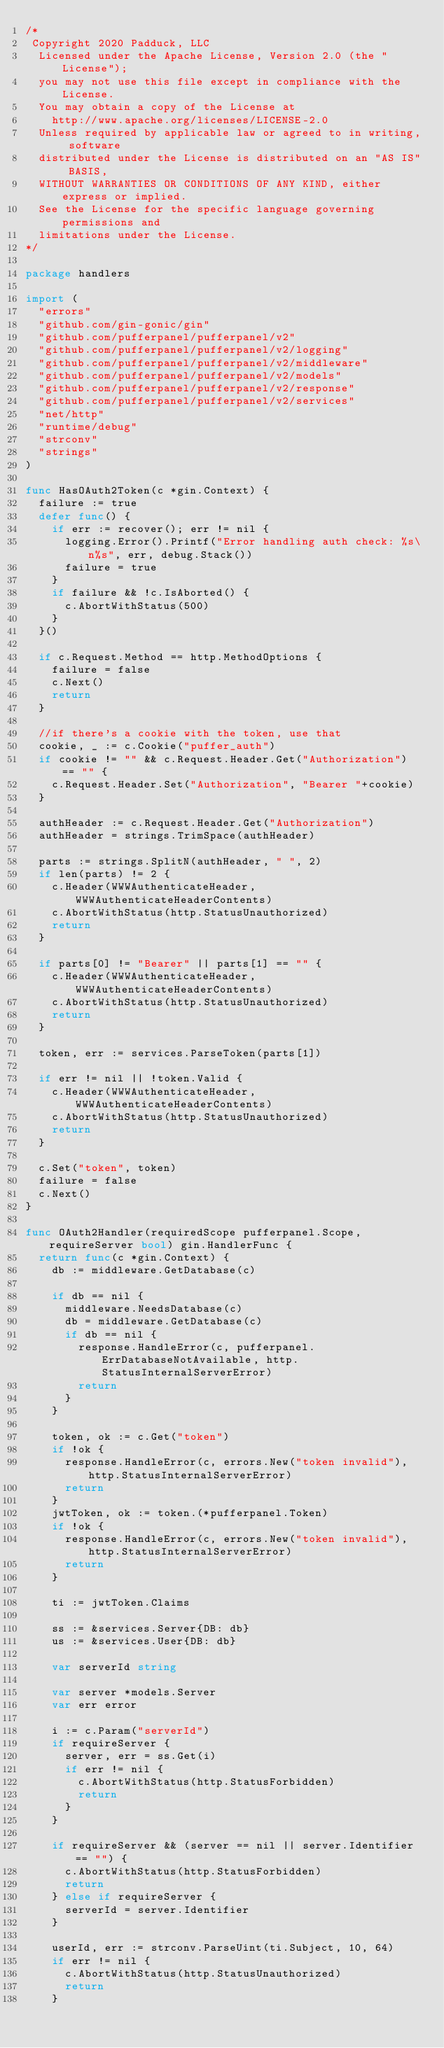Convert code to text. <code><loc_0><loc_0><loc_500><loc_500><_Go_>/*
 Copyright 2020 Padduck, LLC
  Licensed under the Apache License, Version 2.0 (the "License");
  you may not use this file except in compliance with the License.
  You may obtain a copy of the License at
  	http://www.apache.org/licenses/LICENSE-2.0
  Unless required by applicable law or agreed to in writing, software
  distributed under the License is distributed on an "AS IS" BASIS,
  WITHOUT WARRANTIES OR CONDITIONS OF ANY KIND, either express or implied.
  See the License for the specific language governing permissions and
  limitations under the License.
*/

package handlers

import (
	"errors"
	"github.com/gin-gonic/gin"
	"github.com/pufferpanel/pufferpanel/v2"
	"github.com/pufferpanel/pufferpanel/v2/logging"
	"github.com/pufferpanel/pufferpanel/v2/middleware"
	"github.com/pufferpanel/pufferpanel/v2/models"
	"github.com/pufferpanel/pufferpanel/v2/response"
	"github.com/pufferpanel/pufferpanel/v2/services"
	"net/http"
	"runtime/debug"
	"strconv"
	"strings"
)

func HasOAuth2Token(c *gin.Context) {
	failure := true
	defer func() {
		if err := recover(); err != nil {
			logging.Error().Printf("Error handling auth check: %s\n%s", err, debug.Stack())
			failure = true
		}
		if failure && !c.IsAborted() {
			c.AbortWithStatus(500)
		}
	}()

	if c.Request.Method == http.MethodOptions {
		failure = false
		c.Next()
		return
	}

	//if there's a cookie with the token, use that
	cookie, _ := c.Cookie("puffer_auth")
	if cookie != "" && c.Request.Header.Get("Authorization") == "" {
		c.Request.Header.Set("Authorization", "Bearer "+cookie)
	}

	authHeader := c.Request.Header.Get("Authorization")
	authHeader = strings.TrimSpace(authHeader)

	parts := strings.SplitN(authHeader, " ", 2)
	if len(parts) != 2 {
		c.Header(WWWAuthenticateHeader, WWWAuthenticateHeaderContents)
		c.AbortWithStatus(http.StatusUnauthorized)
		return
	}

	if parts[0] != "Bearer" || parts[1] == "" {
		c.Header(WWWAuthenticateHeader, WWWAuthenticateHeaderContents)
		c.AbortWithStatus(http.StatusUnauthorized)
		return
	}

	token, err := services.ParseToken(parts[1])

	if err != nil || !token.Valid {
		c.Header(WWWAuthenticateHeader, WWWAuthenticateHeaderContents)
		c.AbortWithStatus(http.StatusUnauthorized)
		return
	}

	c.Set("token", token)
	failure = false
	c.Next()
}

func OAuth2Handler(requiredScope pufferpanel.Scope, requireServer bool) gin.HandlerFunc {
	return func(c *gin.Context) {
		db := middleware.GetDatabase(c)

		if db == nil {
			middleware.NeedsDatabase(c)
			db = middleware.GetDatabase(c)
			if db == nil {
				response.HandleError(c, pufferpanel.ErrDatabaseNotAvailable, http.StatusInternalServerError)
				return
			}
		}

		token, ok := c.Get("token")
		if !ok {
			response.HandleError(c, errors.New("token invalid"), http.StatusInternalServerError)
			return
		}
		jwtToken, ok := token.(*pufferpanel.Token)
		if !ok {
			response.HandleError(c, errors.New("token invalid"), http.StatusInternalServerError)
			return
		}

		ti := jwtToken.Claims

		ss := &services.Server{DB: db}
		us := &services.User{DB: db}

		var serverId string

		var server *models.Server
		var err error

		i := c.Param("serverId")
		if requireServer {
			server, err = ss.Get(i)
			if err != nil {
				c.AbortWithStatus(http.StatusForbidden)
				return
			}
		}

		if requireServer && (server == nil || server.Identifier == "") {
			c.AbortWithStatus(http.StatusForbidden)
			return
		} else if requireServer {
			serverId = server.Identifier
		}

		userId, err := strconv.ParseUint(ti.Subject, 10, 64)
		if err != nil {
			c.AbortWithStatus(http.StatusUnauthorized)
			return
		}
</code> 